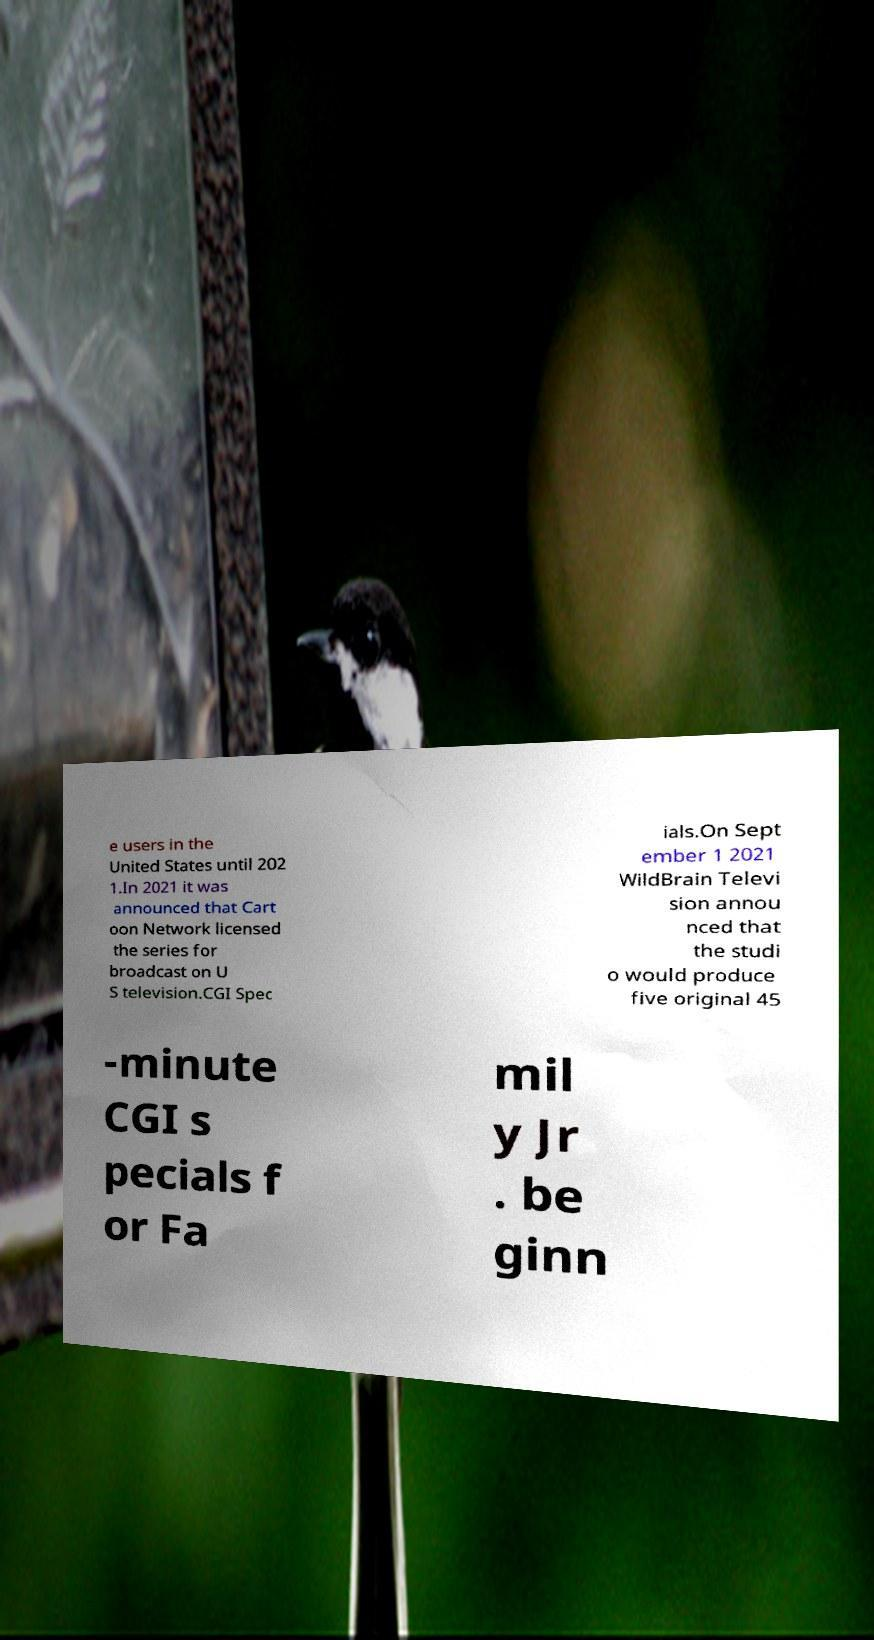Can you read and provide the text displayed in the image?This photo seems to have some interesting text. Can you extract and type it out for me? e users in the United States until 202 1.In 2021 it was announced that Cart oon Network licensed the series for broadcast on U S television.CGI Spec ials.On Sept ember 1 2021 WildBrain Televi sion annou nced that the studi o would produce five original 45 -minute CGI s pecials f or Fa mil y Jr . be ginn 